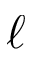Convert formula to latex. <formula><loc_0><loc_0><loc_500><loc_500>\ell</formula> 